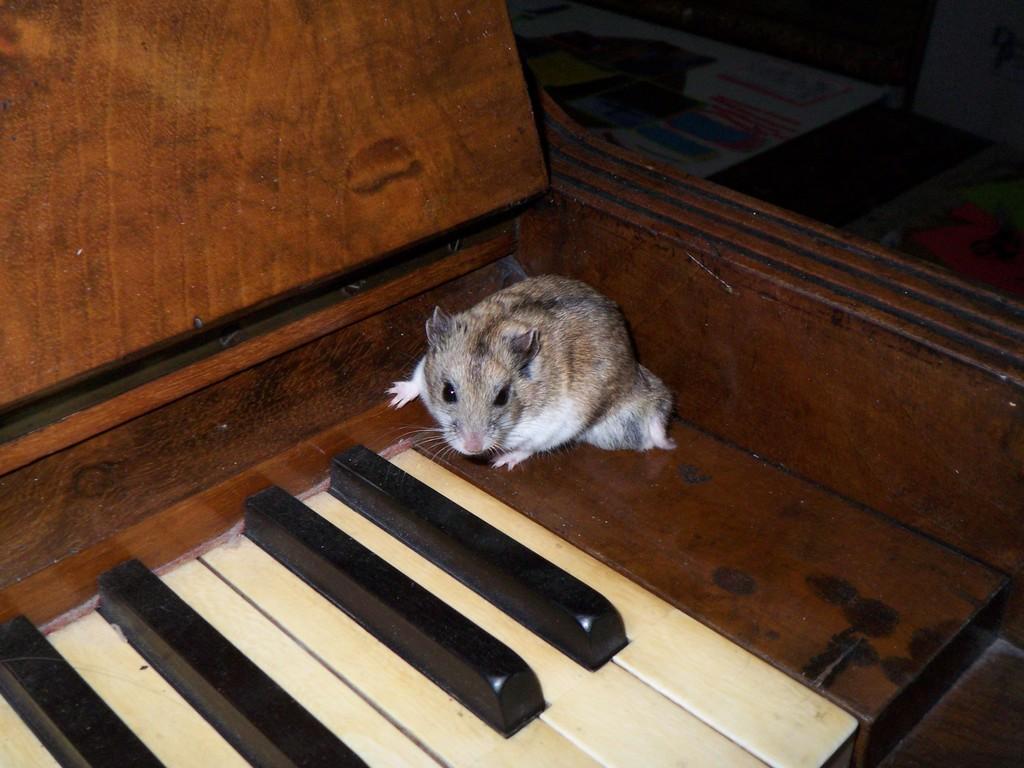How would you summarize this image in a sentence or two? In this image at the bottom there is a piano, and on the piano there is a rat. And in the background there are some boards. 